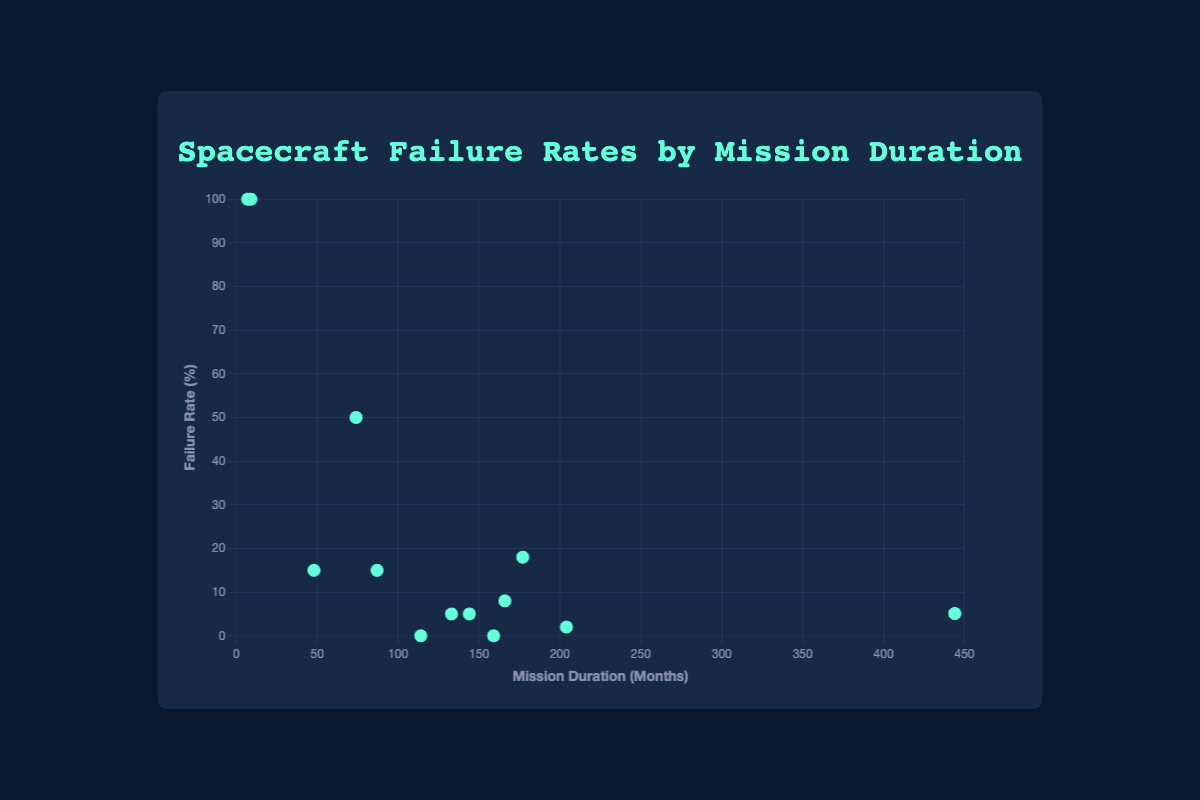Which mission has the highest failure rate? The plot shows dots representing each mission's failure rate. The Mars Climate Orbiter and Phobos 2 both have the highest failure rate at 100%.
Answer: Mars Climate Orbiter and Phobos 2 Which mission has the longest duration with a failure rate of 0%? Find the missions with a failure rate of 0%; Cassini-Huygens and New Horizons. Cassini-Huygens has the longest duration at 159 months.
Answer: Cassini-Huygens How many missions have a failure rate below 10%? Identify the dots below 10% on the y-axis: Voyager 1, Voyager 2, Mars Reconnaissance Orbiter, Pioneer 10, Pioneer 11, New Horizons, and Cassini-Huygens. There are 7 missions.
Answer: 7 Which mission has the shortest duration and a failure rate of more than 50%? Look for points where the failure rate exceeds 50%. Identify the mission with the lowest x-value (duration). Phobos 2 has the shortest duration at 7 months.
Answer: Phobos 2 What is the combined failure rate of missions with durations longer than 200 months? Voyager 1 and Voyager 2 have durations longer than 200 months, each with a failure rate of 5.1%. Adding these together, 5.1% + 5.1% = 10.2%.
Answer: 10.2% Does any mission with a duration between 50 and 100 months have a failure rate higher than 50%? Identify points within the range of 50 to 100 months. Spirit has a failure rate of 50%, and Viking 1 has a failure rate of 15%, so none have more than 50%.
Answer: No Is there any mission with a failure rate of 0% and lasting longer than 150 months? Cassini-Huygens lasts 159 months with a 0% failure rate. There is no mission other than Cassini-Huygens matching this criterion.
Answer: Yes, Cassini-Huygens Compare the failure rates of missions with a duration less than 50 months. Which one has the highest failure rate? Identify the missions with durations less than 50 months: Mars Climate Orbiter (100%), Phobos 2 (100%), and Viking 2 (15%). Mars Climate Orbiter and Phobos 2 both have the highest failure rate of 100%.
Answer: Mars Climate Orbiter and Phobos 2 What is the difference in failure rates between Viking 1 and Viking 2? Viking 1 has a failure rate of 15%, and Viking 2 has a failure rate of 15%. The difference is 15% - 15% = 0.
Answer: 0 What's the average failure rate for missions lasting between 100 and 200 months? Identify the missions in this range: Galileo (8%), New Horizons (0%), Pioneer 10 (5%), and Pioneer 11 (5%). Calculate the average: (8% + 0% + 5% + 5%) / 4 = 18% / 4 = 4.5%.
Answer: 4.5% 